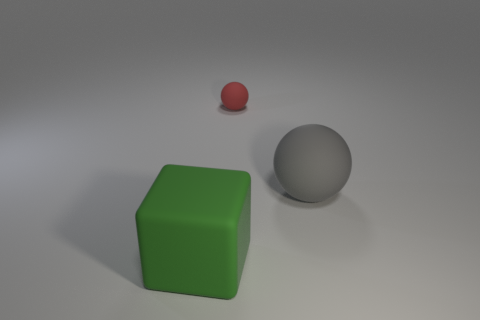There is a sphere to the right of the rubber object that is behind the gray rubber ball right of the small matte object; what is its size?
Keep it short and to the point. Large. There is a big rubber object behind the cube; is it the same shape as the red object?
Keep it short and to the point. Yes. What number of things are large cubes or objects that are to the right of the small ball?
Provide a short and direct response. 2. There is a matte thing that is both on the right side of the large green block and on the left side of the big gray object; what color is it?
Provide a short and direct response. Red. Is the red ball the same size as the green thing?
Keep it short and to the point. No. There is a big thing that is in front of the gray matte ball; what is its color?
Give a very brief answer. Green. There is a cube that is the same size as the gray sphere; what is its color?
Your answer should be compact. Green. Is the gray rubber thing the same shape as the big green rubber object?
Offer a terse response. No. What is the color of the tiny matte thing?
Give a very brief answer. Red. There is a rubber thing on the right side of the tiny red rubber thing; is its size the same as the object that is behind the gray rubber sphere?
Provide a succinct answer. No. 